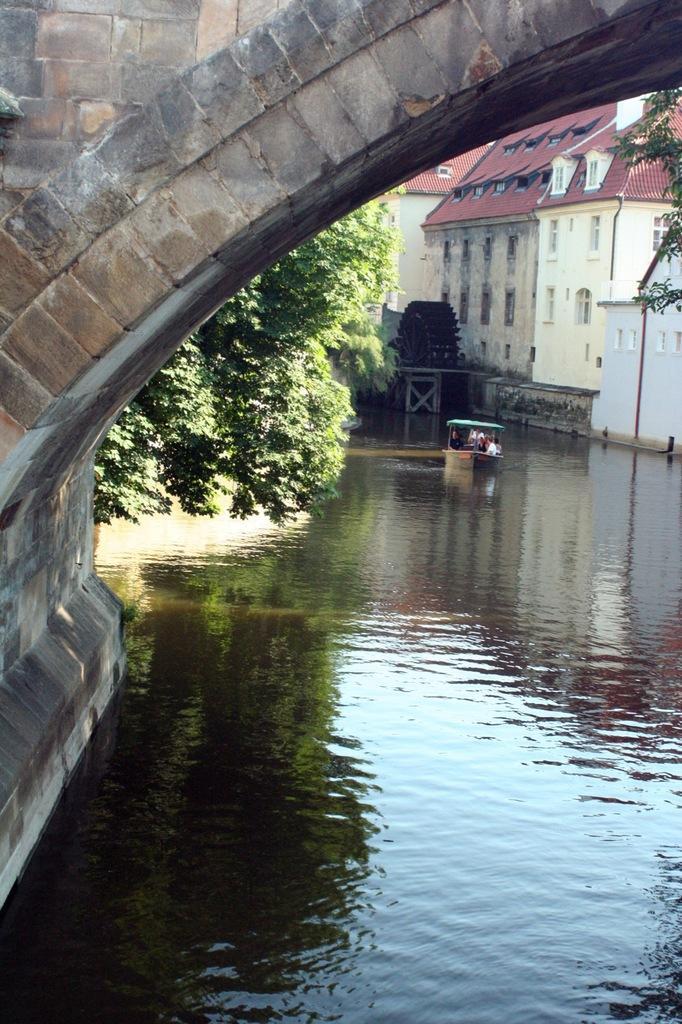Please provide a concise description of this image. In this picture I can see there is a bridge, lake, trees and a building. 